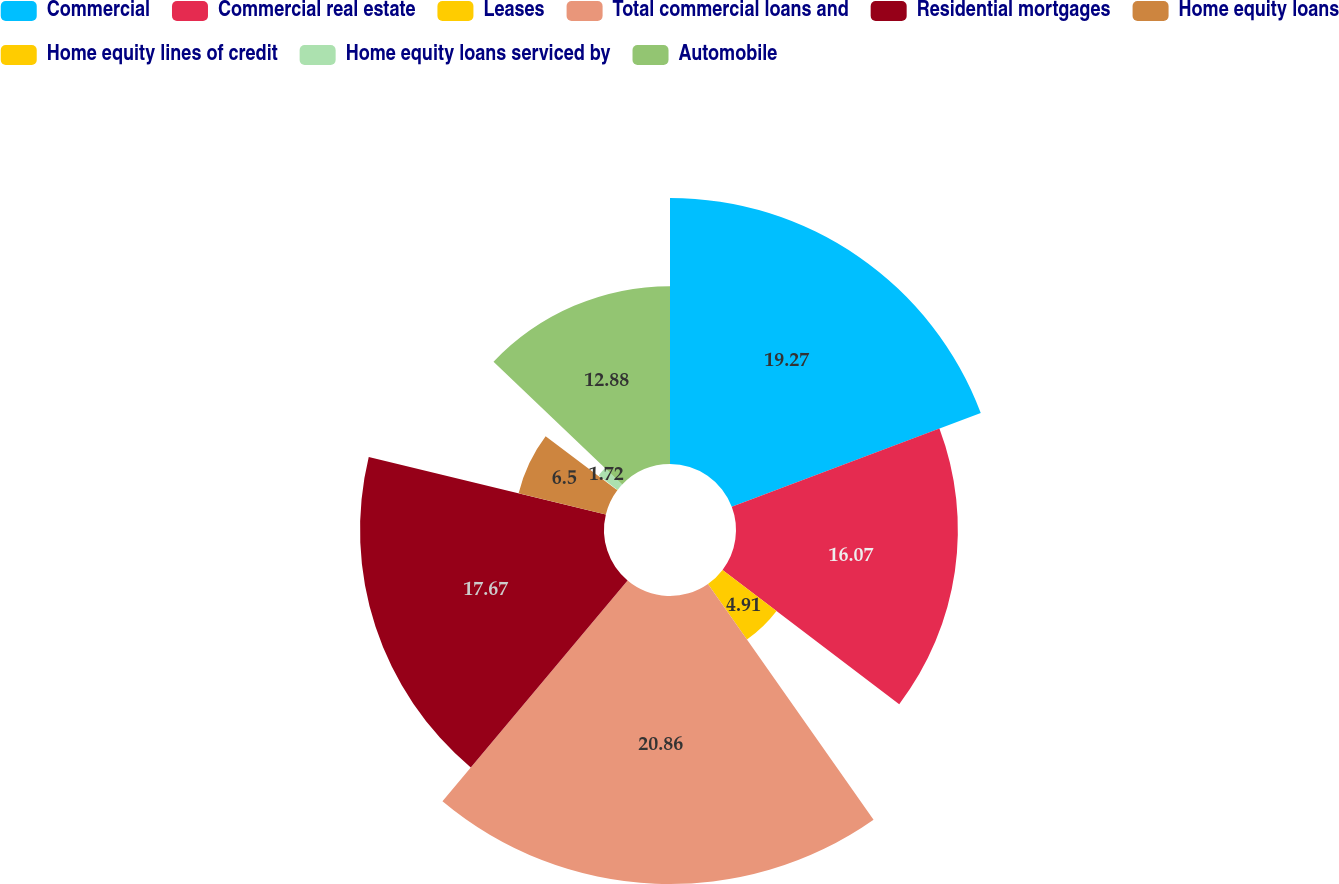<chart> <loc_0><loc_0><loc_500><loc_500><pie_chart><fcel>Commercial<fcel>Commercial real estate<fcel>Leases<fcel>Total commercial loans and<fcel>Residential mortgages<fcel>Home equity loans<fcel>Home equity lines of credit<fcel>Home equity loans serviced by<fcel>Automobile<nl><fcel>19.27%<fcel>16.07%<fcel>4.91%<fcel>20.86%<fcel>17.67%<fcel>6.5%<fcel>0.12%<fcel>1.72%<fcel>12.88%<nl></chart> 